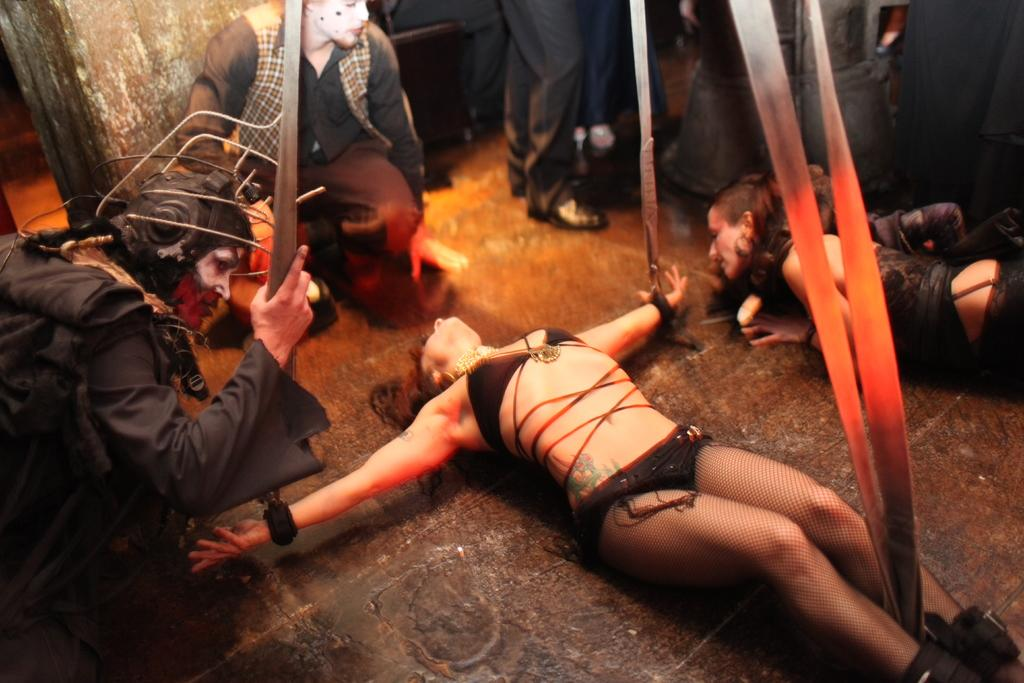What is the main subject of the image? There is a beautiful woman laying on the floor in the middle of the image. What are the two people on the left side of the image doing? The two people on the left side of the image are performing a Halloween activity. What type of bells can be heard ringing in the background of the image? There are no bells present in the image, and therefore no sound can be heard. 